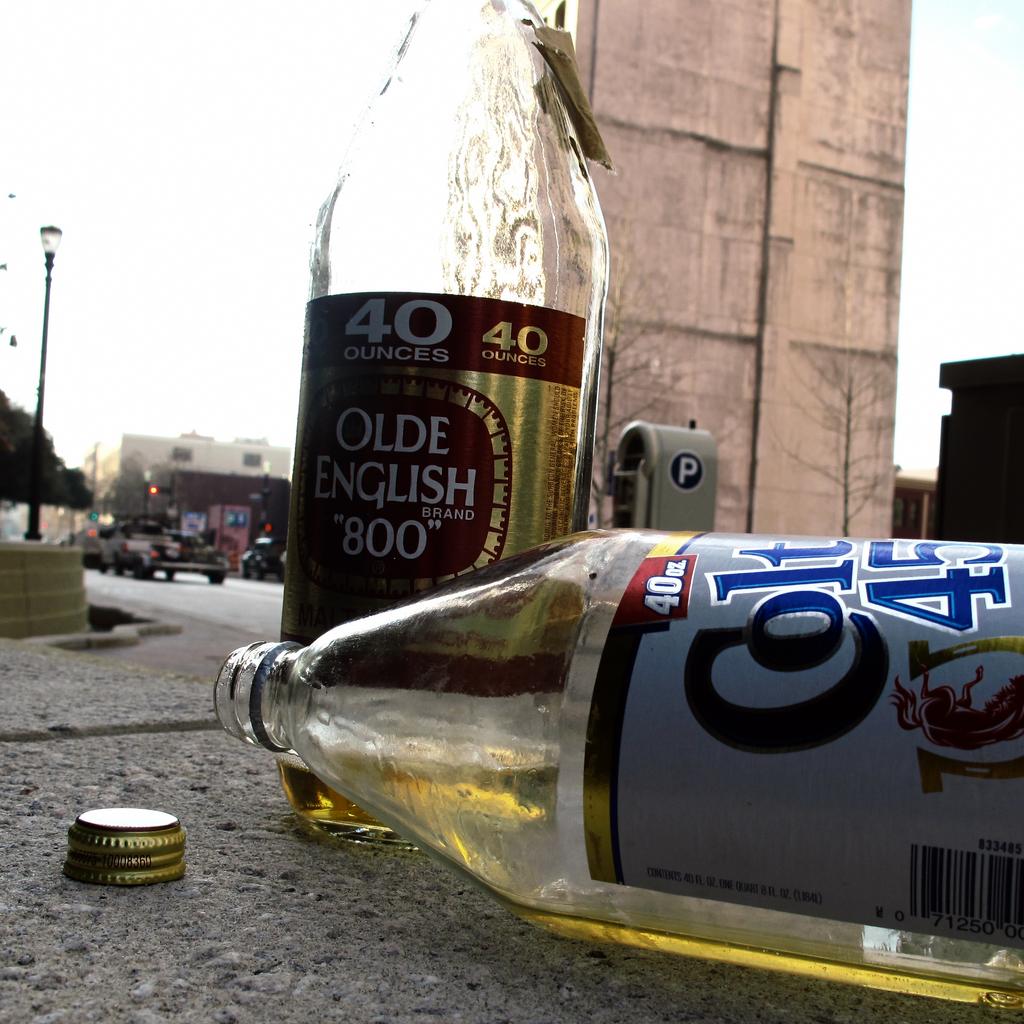What is the brand of this beverage?
Make the answer very short. Olde english. 